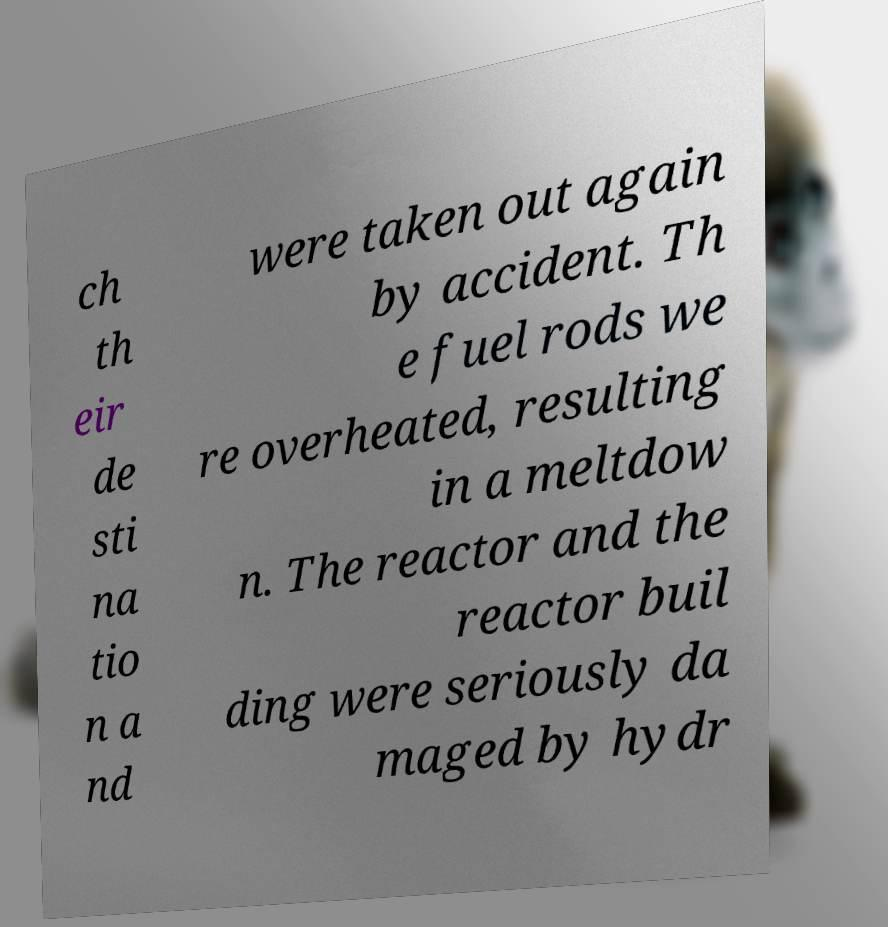Could you extract and type out the text from this image? ch th eir de sti na tio n a nd were taken out again by accident. Th e fuel rods we re overheated, resulting in a meltdow n. The reactor and the reactor buil ding were seriously da maged by hydr 